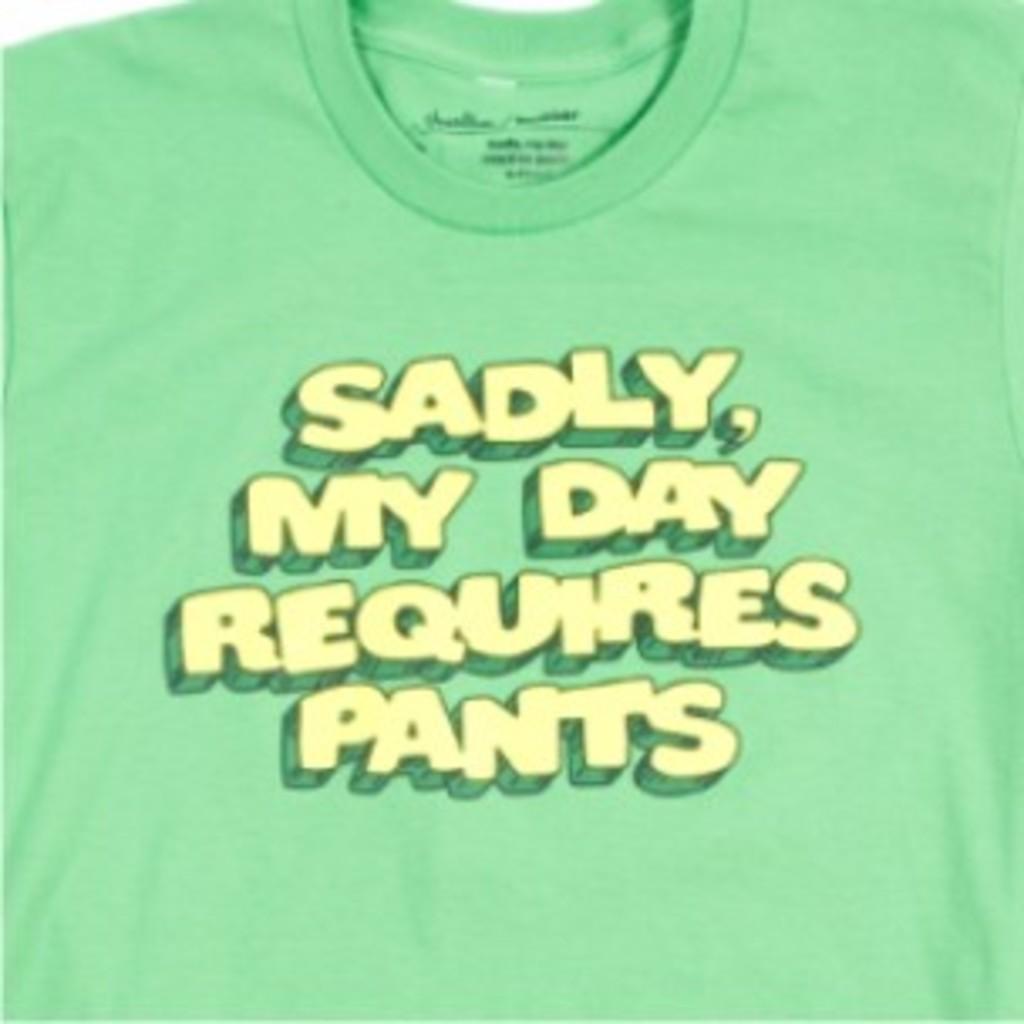How would you summarize this image in a sentence or two? In this image there is a green T-shirt, on that there is some text. 